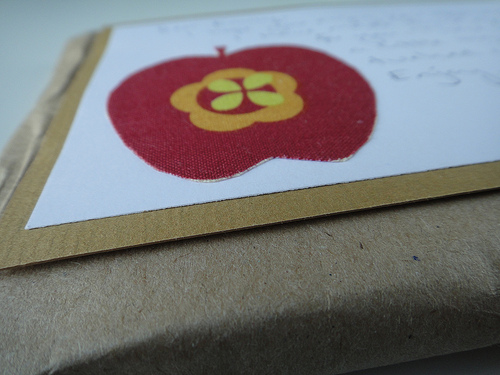<image>
Can you confirm if the paper is in front of the apple? No. The paper is not in front of the apple. The spatial positioning shows a different relationship between these objects. 